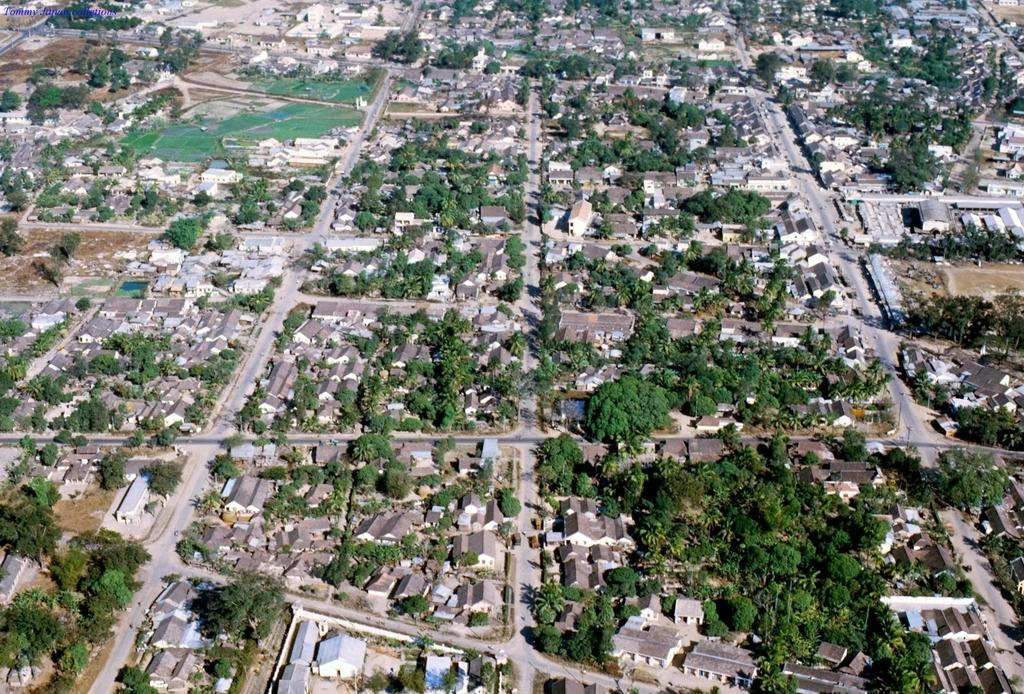What type of natural elements can be seen in the image? There are trees in the image. What type of man-made structures are present in the image? There are buildings in the image. What type of transportation infrastructure is visible in the image? There are roads in the image. Can you describe any other objects or features in the image? There are unspecified objects in the image. What type of leather material is used to construct the buildings in the image? There is no mention of leather or any specific building materials in the image. 